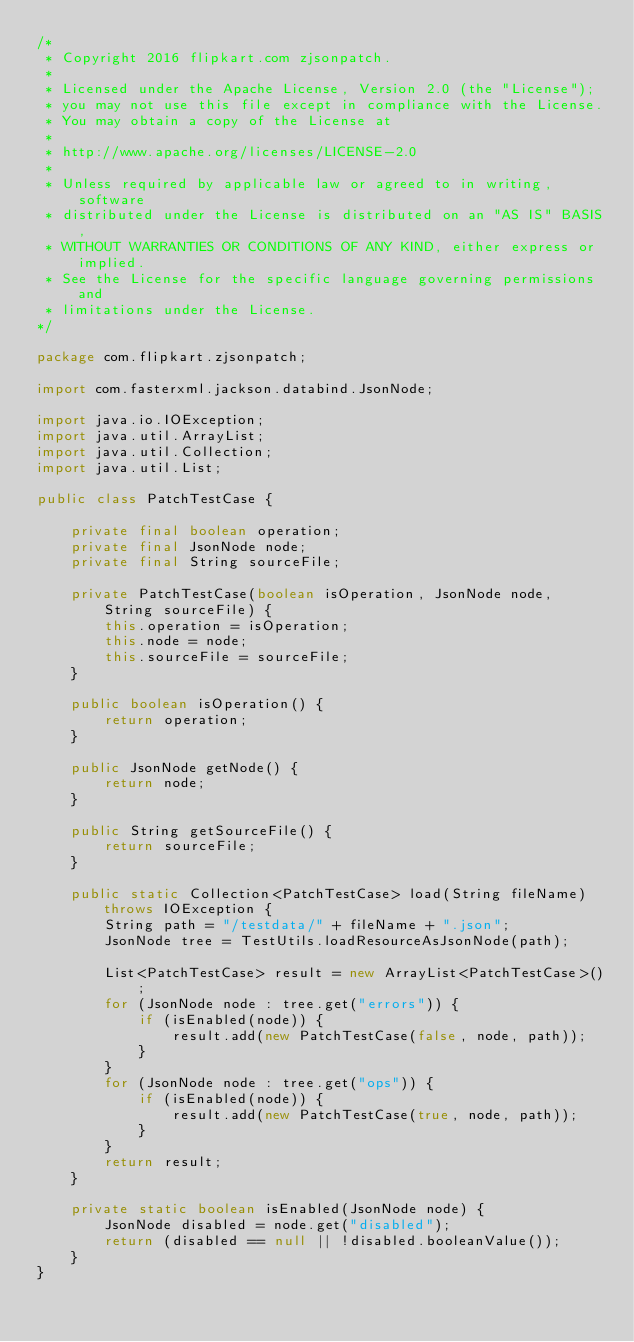Convert code to text. <code><loc_0><loc_0><loc_500><loc_500><_Java_>/*
 * Copyright 2016 flipkart.com zjsonpatch.
 *
 * Licensed under the Apache License, Version 2.0 (the "License");
 * you may not use this file except in compliance with the License.
 * You may obtain a copy of the License at
 *
 * http://www.apache.org/licenses/LICENSE-2.0
 *
 * Unless required by applicable law or agreed to in writing, software
 * distributed under the License is distributed on an "AS IS" BASIS,
 * WITHOUT WARRANTIES OR CONDITIONS OF ANY KIND, either express or implied.
 * See the License for the specific language governing permissions and
 * limitations under the License.
*/

package com.flipkart.zjsonpatch;

import com.fasterxml.jackson.databind.JsonNode;

import java.io.IOException;
import java.util.ArrayList;
import java.util.Collection;
import java.util.List;

public class PatchTestCase {

    private final boolean operation;
    private final JsonNode node;
    private final String sourceFile;

    private PatchTestCase(boolean isOperation, JsonNode node, String sourceFile) {
        this.operation = isOperation;
        this.node = node;
        this.sourceFile = sourceFile;
    }

    public boolean isOperation() {
        return operation;
    }

    public JsonNode getNode() {
        return node;
    }

    public String getSourceFile() {
        return sourceFile;
    }

    public static Collection<PatchTestCase> load(String fileName) throws IOException {
        String path = "/testdata/" + fileName + ".json";
        JsonNode tree = TestUtils.loadResourceAsJsonNode(path);

        List<PatchTestCase> result = new ArrayList<PatchTestCase>();
        for (JsonNode node : tree.get("errors")) {
            if (isEnabled(node)) {
                result.add(new PatchTestCase(false, node, path));
            }
        }
        for (JsonNode node : tree.get("ops")) {
            if (isEnabled(node)) {
                result.add(new PatchTestCase(true, node, path));
            }
        }
        return result;
    }

    private static boolean isEnabled(JsonNode node) {
        JsonNode disabled = node.get("disabled");
        return (disabled == null || !disabled.booleanValue());
    }
}
</code> 